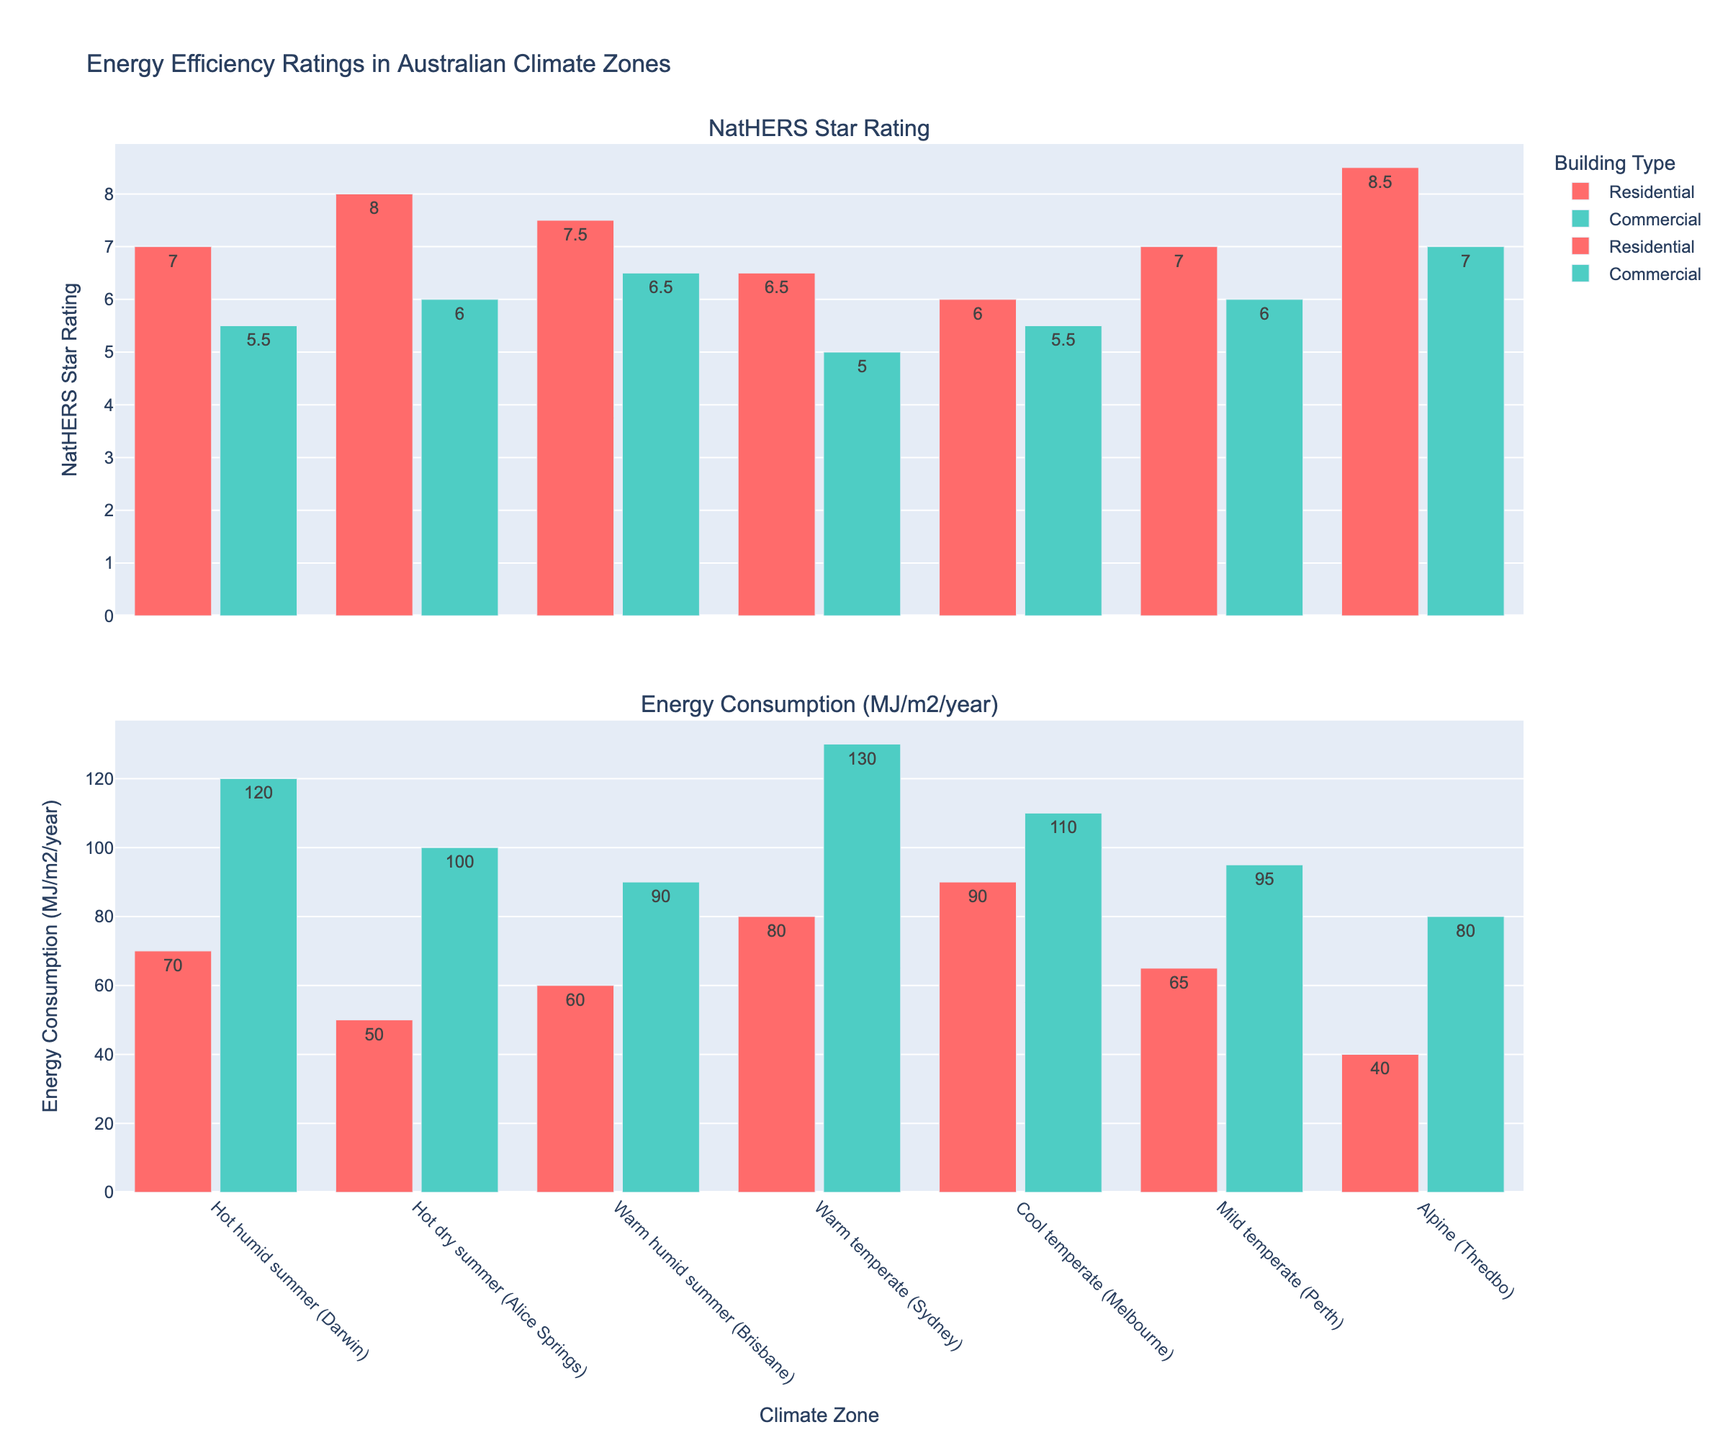What is the NatHERS Star Rating for Residential buildings in the Alpine (Thredbo) climate zone? Look at the NatHERS Star Rating subplot and identify the bar representing Residential buildings in the Alpine (Thredbo) climate zone, which is tagged with its value.
Answer: 8.5 How does the energy consumption of Commercial buildings in Warm temperate (Sydney) compare to Cool temperate (Melbourne)? Compare the heights of the bars for Commercial buildings in the Energy Consumption subplot. The bar for Cool temperate (Melbourne) is 110 MJ/m²/year, while the bar for Warm temperate (Sydney) is 130 MJ/m²/year.
Answer: Warm temperate (Sydney) is higher Which climate zone shows the highest NatHERS Star Rating for Commercial buildings? In the NatHERS Star Rating subplot, find and compare the heights of all bars representing Commercial buildings. The highest bar represents the Alpine (Thredbo) climate zone with a value of 7 stars.
Answer: Alpine (Thredbo) What is the difference in energy consumption between Residential and Commercial buildings in Hot humid summer (Darwin)? From the Energy Consumption subplot, find the bars for Hot humid summer (Darwin) and subtract the value for Residential (70 MJ/m²/year) from Commercial (120 MJ/m²/year).
Answer: 50 MJ/m²/year What is the average NatHERS Star Rating for Residential buildings across all climate zones? Find all values for Residential buildings in the NatHERS Star Rating subplot: (7, 8, 7.5, 6.5, 6, 7, 8.5). Add these values and divide by the number of values (7). Sum = 50.5, Average = 50.5/7 = 7.21
Answer: 7.21 Between Residential buildings in Hot dry summer (Alice Springs) and Mild temperate (Perth), which has lower energy consumption? In the Energy Consumption subplot, compare the heights of the bars for Residential buildings in Hot dry summer (Alice Springs) and Mild temperate (Perth). Alice Springs is 50 MJ/m²/year, and Perth is 65 MJ/m²/year.
Answer: Hot dry summer (Alice Springs) Which building type in Cool temperate (Melbourne) has a higher NatHERS Star Rating? In the NatHERS Star Rating subplot for Cool temperate (Melbourne), compare the values for both Residential (6) and Commercial (5.5) buildings.
Answer: Residential How much more energy does a Commercial building consume in Warm humid summer (Brisbane) than a Residential building? From the Energy Consumption subplot, subtract the value for Residential (60 MJ/m²/year) from Commercial (90 MJ/m²/year) in Warm humid summer (Brisbane).
Answer: 30 MJ/m²/year What is the highest energy consumption value among all the Residential buildings across the climate zones? In the Energy Consumption subplot, identify the bar with the highest value for Residential buildings, which is Cool temperate (Melbourne) at 90 MJ/m²/year.
Answer: 90 MJ/m²/year Is there any climate zone where both Residential and Commercial buildings have the same NatHERS Star Rating? Compare all paired values for both building types in the NatHERS Star Rating subplot. There is no climate zone where both building types have the same star rating.
Answer: No 